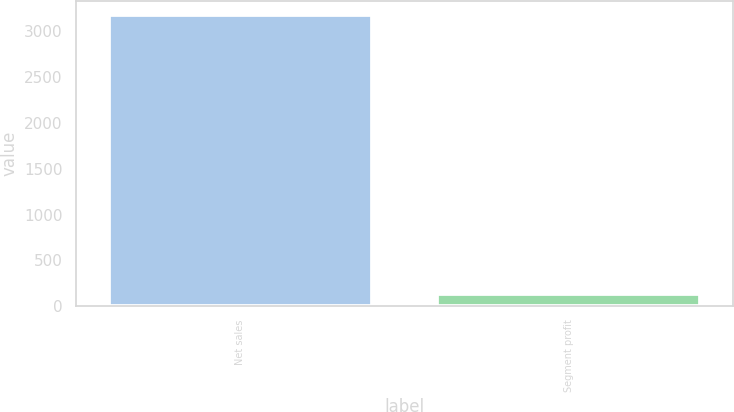Convert chart to OTSL. <chart><loc_0><loc_0><loc_500><loc_500><bar_chart><fcel>Net sales<fcel>Segment profit<nl><fcel>3169<fcel>136<nl></chart> 